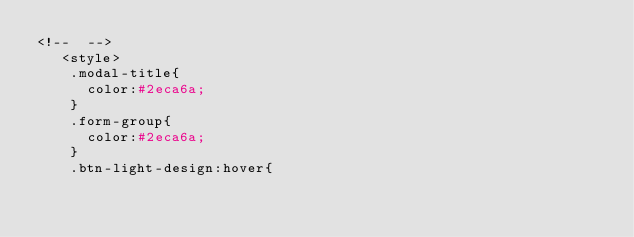<code> <loc_0><loc_0><loc_500><loc_500><_PHP_><!--  -->
   <style>
    .modal-title{
      color:#2eca6a;
    }
    .form-group{
      color:#2eca6a;
    }
    .btn-light-design:hover{</code> 